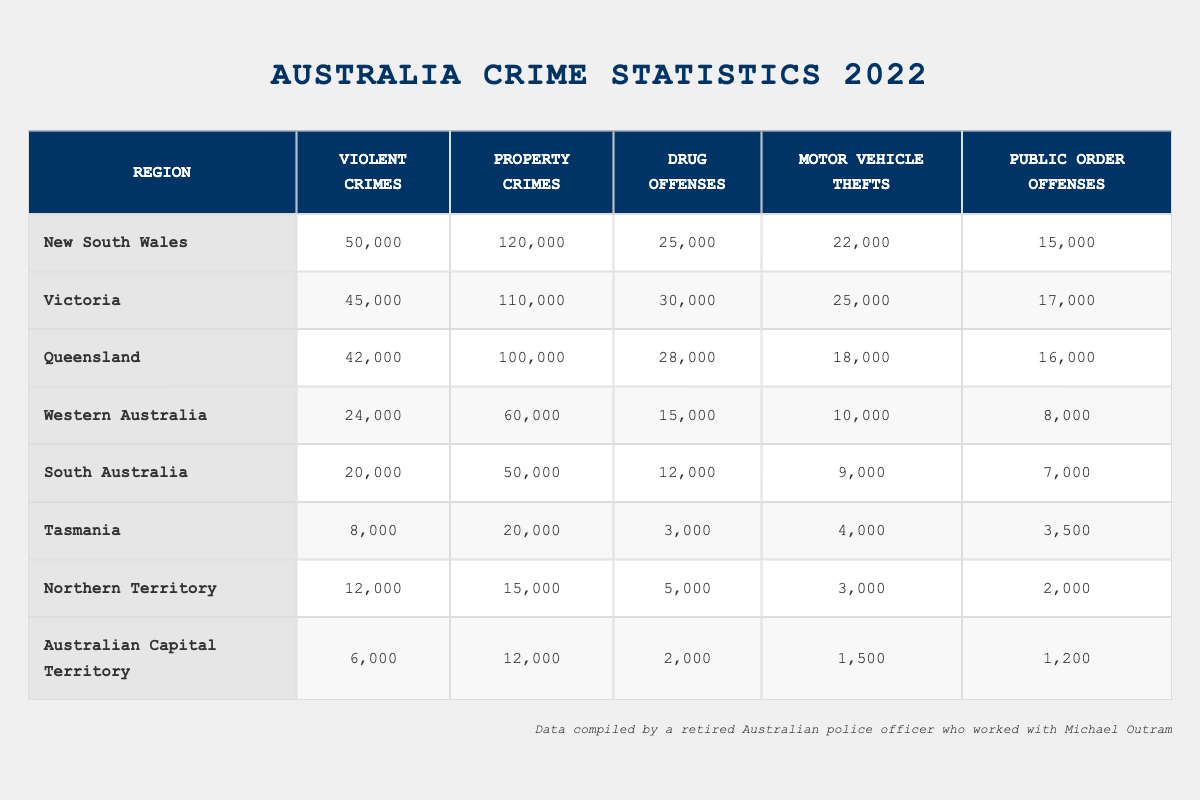What region has the highest number of violent crimes? The table lists the number of violent crimes for each region. The highest value is found in New South Wales, which has 50,000 violent crimes.
Answer: New South Wales Which region reports the lowest number of drug offenses? Looking at the drug offenses column, Tasmania lists the lowest number at 3,000 offenses.
Answer: Tasmania What is the total number of property crimes reported in Queensland and South Australia combined? To find the total, we need to add the property crimes from both regions: Queensland (100,000) + South Australia (50,000) = 150,000.
Answer: 150,000 Is the number of public order offenses in Victoria greater than in Western Australia? Checking the public order offenses column, Victoria has 17,000 and Western Australia has 8,000. Since 17,000 is greater than 8,000, the statement is true.
Answer: Yes What is the average number of motor vehicle thefts across all regions? To find the average, we first sum the motor vehicle thefts: 22,000 + 25,000 + 18,000 + 10,000 + 9,000 + 4,000 + 3,000 + 1,500 = 92,500. There are 8 regions, so the average is 92,500 / 8 = 11,562.5.
Answer: 11,562.5 Which region has a higher number of violent crimes, Queensland or Western Australia? Queensland reports 42,000 violent crimes while Western Australia reports only 24,000. Since 42,000 is greater than 24,000, Queensland has a higher number.
Answer: Queensland How many more drug offenses are reported in Victoria compared to Tasmania? The difference can be found by subtracting the drug offenses in Tasmania (3,000) from those in Victoria (30,000): 30,000 - 3,000 = 27,000.
Answer: 27,000 Are there more property crimes in New South Wales than in South Australia? New South Wales reports 120,000 property crimes and South Australia reports 50,000. Since 120,000 is greater than 50,000, the statement is true.
Answer: Yes What is the total number of violent crimes across all regions listed? To find the total, we sum the violent crimes for all regions: 50,000 + 45,000 + 42,000 + 24,000 + 20,000 + 8,000 + 12,000 + 6,000 = 207,000.
Answer: 207,000 